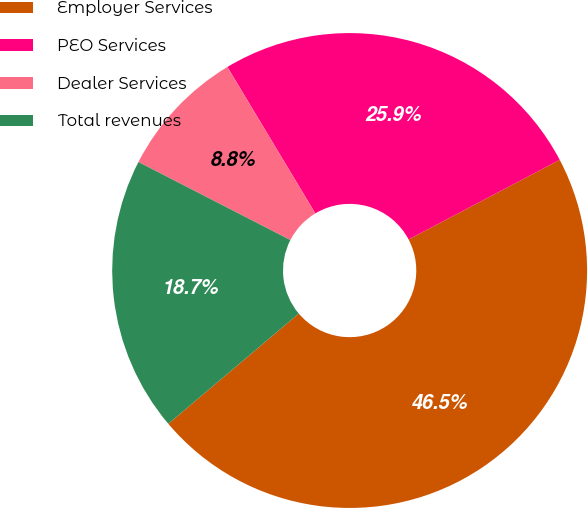Convert chart to OTSL. <chart><loc_0><loc_0><loc_500><loc_500><pie_chart><fcel>Employer Services<fcel>PEO Services<fcel>Dealer Services<fcel>Total revenues<nl><fcel>46.55%<fcel>25.89%<fcel>8.84%<fcel>18.72%<nl></chart> 